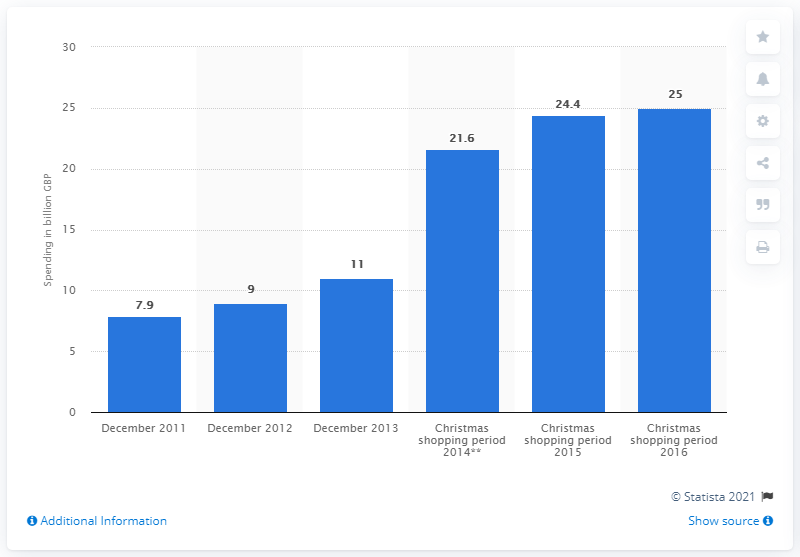List a handful of essential elements in this visual. Online Christmas spending in 2016 amounted to approximately $25 billion. 